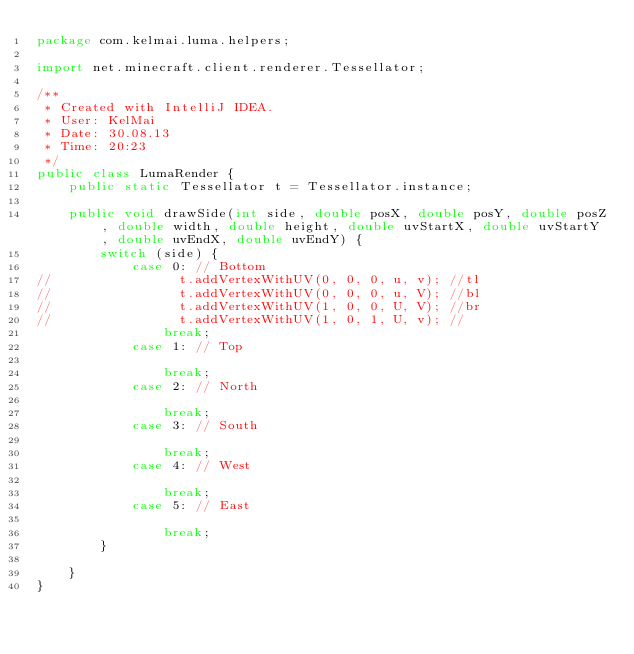Convert code to text. <code><loc_0><loc_0><loc_500><loc_500><_Java_>package com.kelmai.luma.helpers;

import net.minecraft.client.renderer.Tessellator;

/**
 * Created with IntelliJ IDEA.
 * User: KelMai
 * Date: 30.08.13
 * Time: 20:23
 */
public class LumaRender {
    public static Tessellator t = Tessellator.instance;

    public void drawSide(int side, double posX, double posY, double posZ, double width, double height, double uvStartX, double uvStartY, double uvEndX, double uvEndY) {
        switch (side) {
            case 0: // Bottom
//                t.addVertexWithUV(0, 0, 0, u, v); //tl
//                t.addVertexWithUV(0, 0, 0, u, V); //bl
//                t.addVertexWithUV(1, 0, 0, U, V); //br
//                t.addVertexWithUV(1, 0, 1, U, v); //
                break;
            case 1: // Top

                break;
            case 2: // North

                break;
            case 3: // South

                break;
            case 4: // West

                break;
            case 5: // East

                break;
        }

    }
}
</code> 